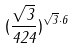Convert formula to latex. <formula><loc_0><loc_0><loc_500><loc_500>( \frac { \sqrt { 3 } } { 4 2 4 } ) ^ { \sqrt { 3 } \cdot 6 }</formula> 